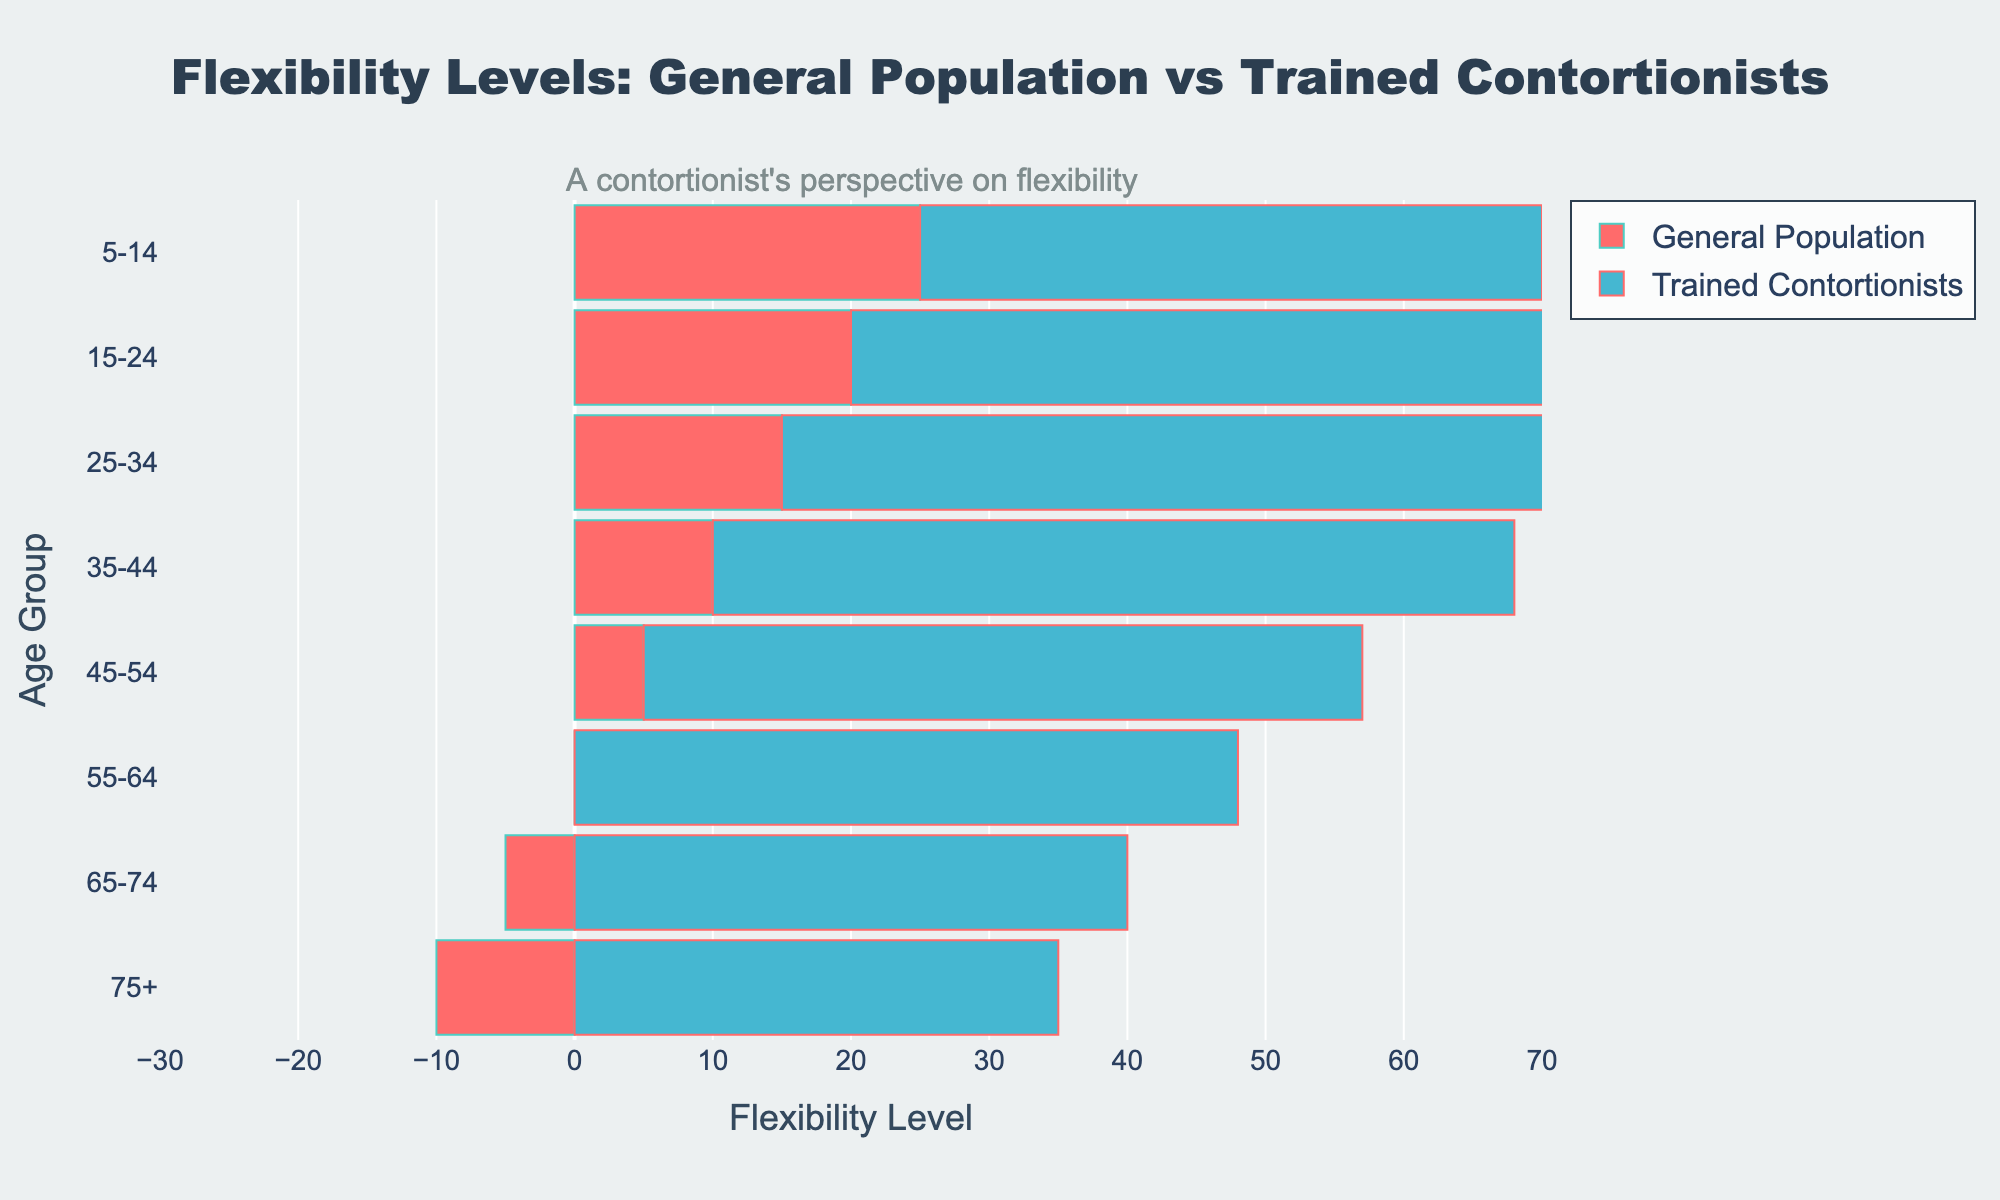What is the title of the figure? The title is located at the top of the figure and reads "Flexibility Levels: General Population vs Trained Contortionists".
Answer: Flexibility Levels: General Population vs Trained Contortionists Which age group has the highest flexibility level among trained contortionists? By observing the right side of the population pyramid, the age group with the highest bar is "25-34".
Answer: 25-34 What is the flexibility level of the general population in the 5-14 age group? The flexibility level for the general population in the 5-14 age group is found by looking at the negative bar on the left side for this age group. The value is -25.
Answer: -25 How do the flexibility levels of the general population and trained contortionists compare in the 35-44 age group? The general population has a flexibility level of -10 and the trained contortionists have 58. By comparing these two values, we see that the trained contortionists have a significantly higher flexibility level.
Answer: Trained contortionists have much higher flexibility Which age group shows the smallest difference in flexibility levels between the general population and trained contortionists? To find the smallest difference, we subtract the flexibility values of the general population from those of the trained contortionists for each age group and look for the smallest result. The difference for each age group is: (5-14: 70), (15-24: 75), (25-34: 75), (35-44: 68), (45-54: 57), (55-64: 48), (65-74: 35), (75+: 25). The age group "75+" has the smallest difference of 25.
Answer: 75+ Which age group shows the greatest improvement in flexibility in trained contortionists compared to the general population? To find the greatest improvement, we subtract the flexibility values of the general population from those of the trained contortionists for each age group. The greatest difference is in the 25-34 age group (60 - (-15) = 75).
Answer: 25-34 Is there any age group where the flexibility level of the trained contortionists decreases compared to the previous younger age group? By observing the bars on the right side of the pyramid from top to bottom (younger to older), the transition from the "25-34" age group to "35-44" shows a slight decrease (from 60 to 58).
Answer: Yes What is the flexibility level of trained contortionists in the 65-74 age group? The flexibility level for trained contortionists in the 65-74 age group can be found by looking at the bar on the right for this age group, which is 40.
Answer: 40 How does the flexibility level change as the age increases for the general population? The flexibility level for the general population increases as the age increases, starting from -25 (5-14 age group) and going up to 10 (75+ age group).
Answer: It increases What are the limits of the x-axis representing flexibility levels? The x-axis stretches from -30 on the left (general population) to 70 on the right (trained contortionists).
Answer: -30 to 70 